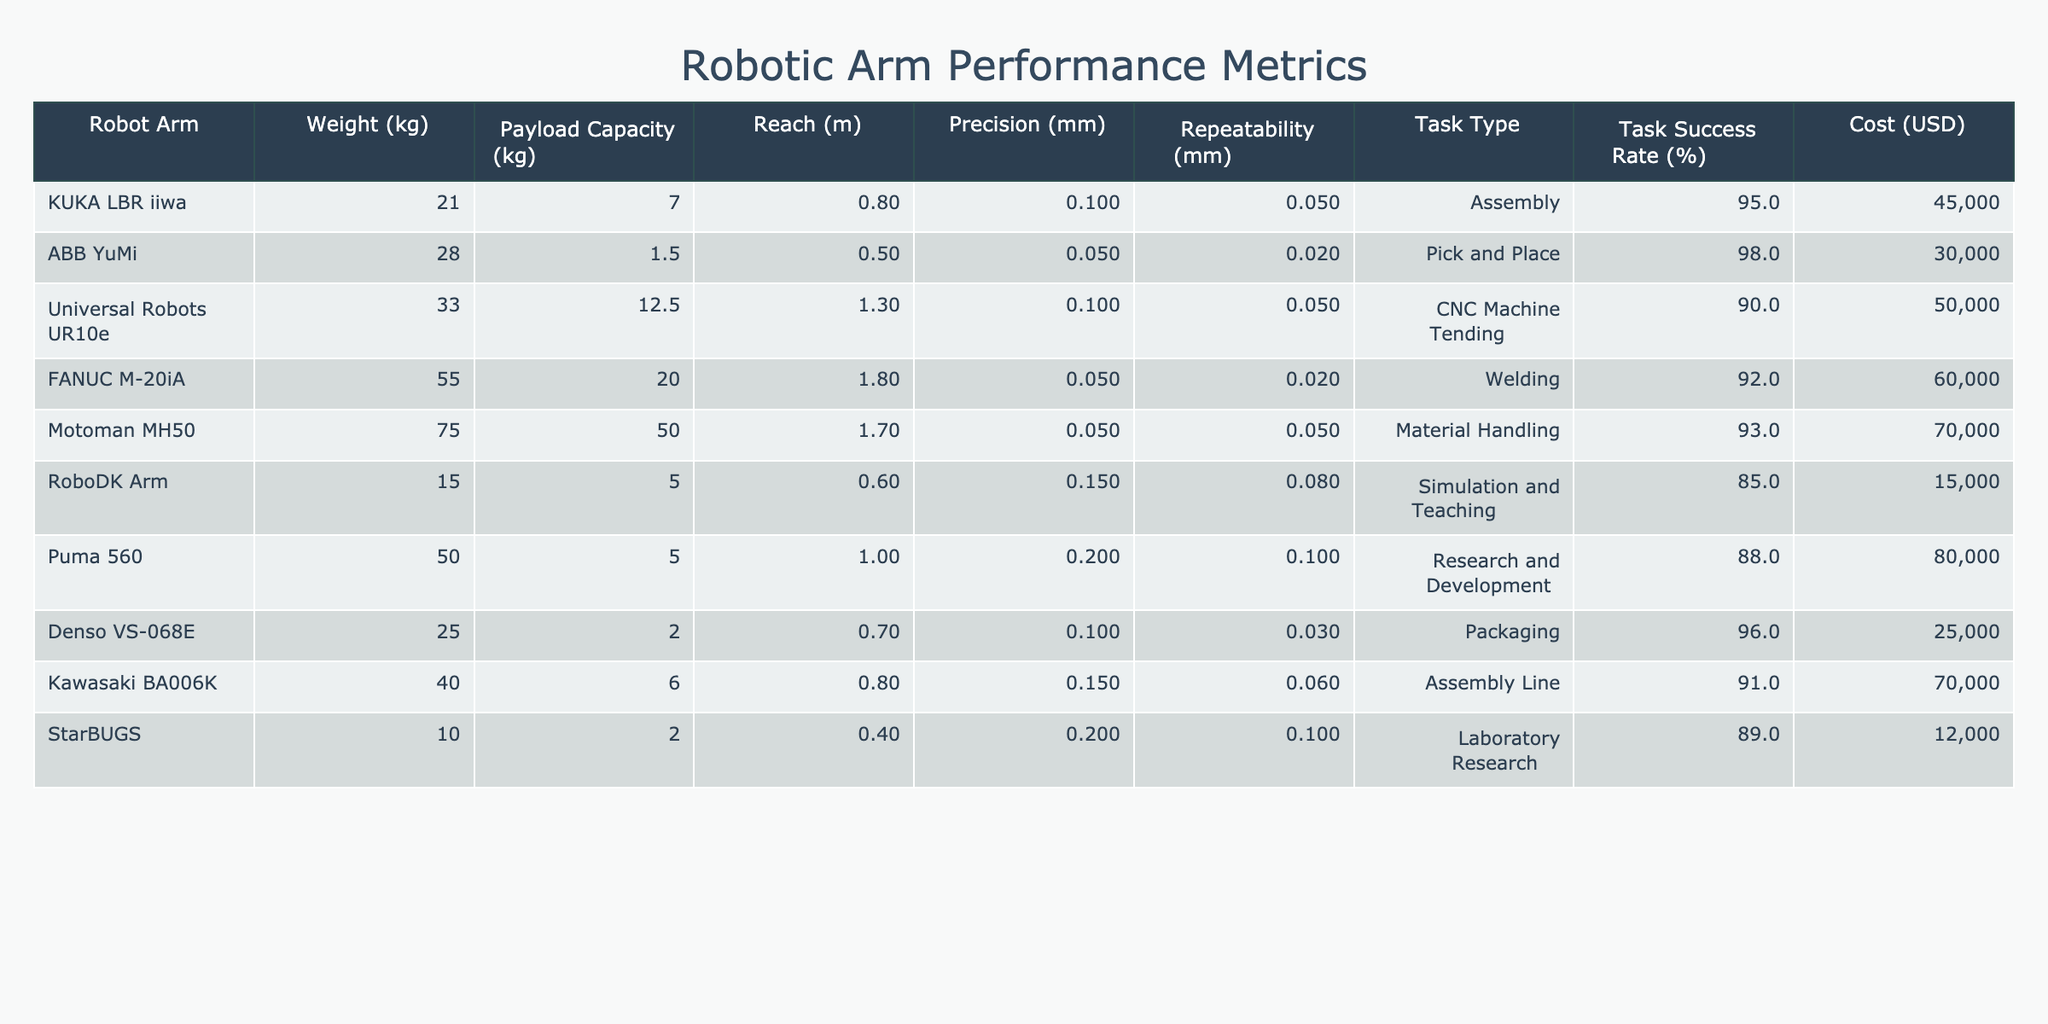What is the payload capacity of the ABB YuMi? The payload capacity for the ABB YuMi is listed in the table under the "Payload Capacity (kg)" column, which shows a value of 1.5 kg.
Answer: 1.5 kg Which robotic arm has the highest task success rate? By comparing the values in the "Task Success Rate (%)" column, the ABB YuMi has the highest success rate at 98%.
Answer: 98% What is the average weight of the robotic arms listed in the table? To find the average weight, first sum the weights: 21 + 28 + 33 + 55 + 75 + 15 + 50 + 25 + 40 + 10 =  388 kg. There are 10 robotic arms, so the average weight is 388 kg / 10 = 38.8 kg.
Answer: 38.8 kg Is the FANUC M-20iA more precise than the KUKA LBR iiwa? The precision of FANUC M-20iA is 0.05 mm and that of KUKA LBR iiwa is 0.1 mm; since 0.05 mm is less than 0.1 mm, FANUC M-20iA is more precise.
Answer: Yes What is the total payload capacity of all robotic arms that have Task Type classified as Assembly? The payload capacities of robotic arms for the Assembly task type are 7 kg (KUKA LBR iiwa) and 6 kg (Kawasaki BA006K). Their total payload capacity is calculated as 7 kg + 6 kg = 13 kg.
Answer: 13 kg How many robotic arms have a task success rate greater than 90%? By checking the "Task Success Rate (%)" column, I count the following arms with rates above 90%: KUKA LBR iiwa (95%), ABB YuMi (98%), FANUC M-20iA (92%), Motoman MH50 (93%), and Kawasaki BA006K (91%). This gives us a total of 5 robotic arms.
Answer: 5 What is the cost difference between the most expensive and the least expensive robotic arms? The most expensive robotic arm is the Motoman MH50 at 70,000 USD, while the least expensive is the RoboDK Arm at 15,000 USD. The difference is calculated as 70,000 USD - 15,000 USD = 55,000 USD.
Answer: 55,000 USD Which robotic arm has both the lowest precision and highest weight? The robotic arm with the lowest precision (0.2 mm) is the Puma 560, which weighs 50 kg. It is the only arm meeting both criteria, so the answer is the Puma 560.
Answer: Puma 560 What is the relationship between payload capacity and task success rate based on the values in the table? To evaluate this relationship, I observe that robotic arms with higher payload capacities (like Motoman MH50) tend to have success rates above 90%, indicating a positive correlation, but further analysis on all arms could provide a clearer pattern.
Answer: Positive correlation 